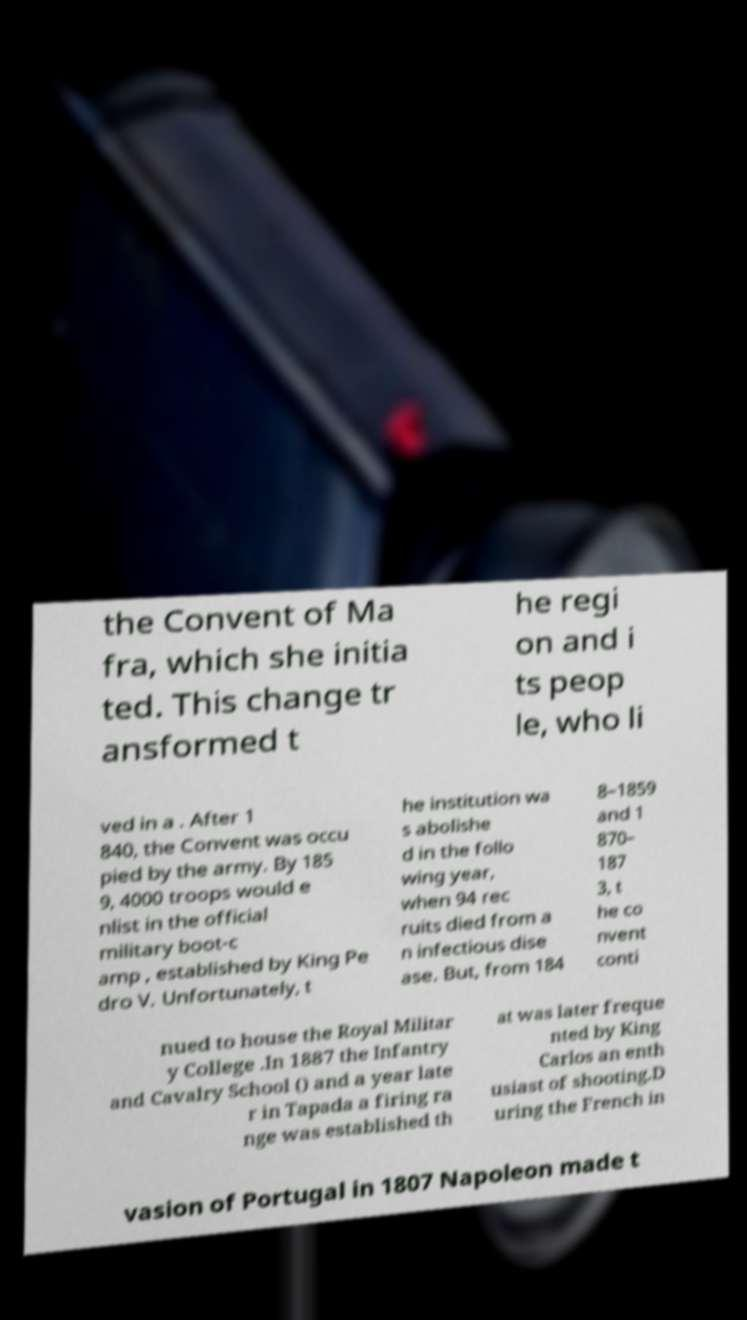What messages or text are displayed in this image? I need them in a readable, typed format. the Convent of Ma fra, which she initia ted. This change tr ansformed t he regi on and i ts peop le, who li ved in a . After 1 840, the Convent was occu pied by the army. By 185 9, 4000 troops would e nlist in the official military boot-c amp , established by King Pe dro V. Unfortunately, t he institution wa s abolishe d in the follo wing year, when 94 rec ruits died from a n infectious dise ase. But, from 184 8–1859 and 1 870– 187 3, t he co nvent conti nued to house the Royal Militar y College .In 1887 the Infantry and Cavalry School () and a year late r in Tapada a firing ra nge was established th at was later freque nted by King Carlos an enth usiast of shooting.D uring the French in vasion of Portugal in 1807 Napoleon made t 